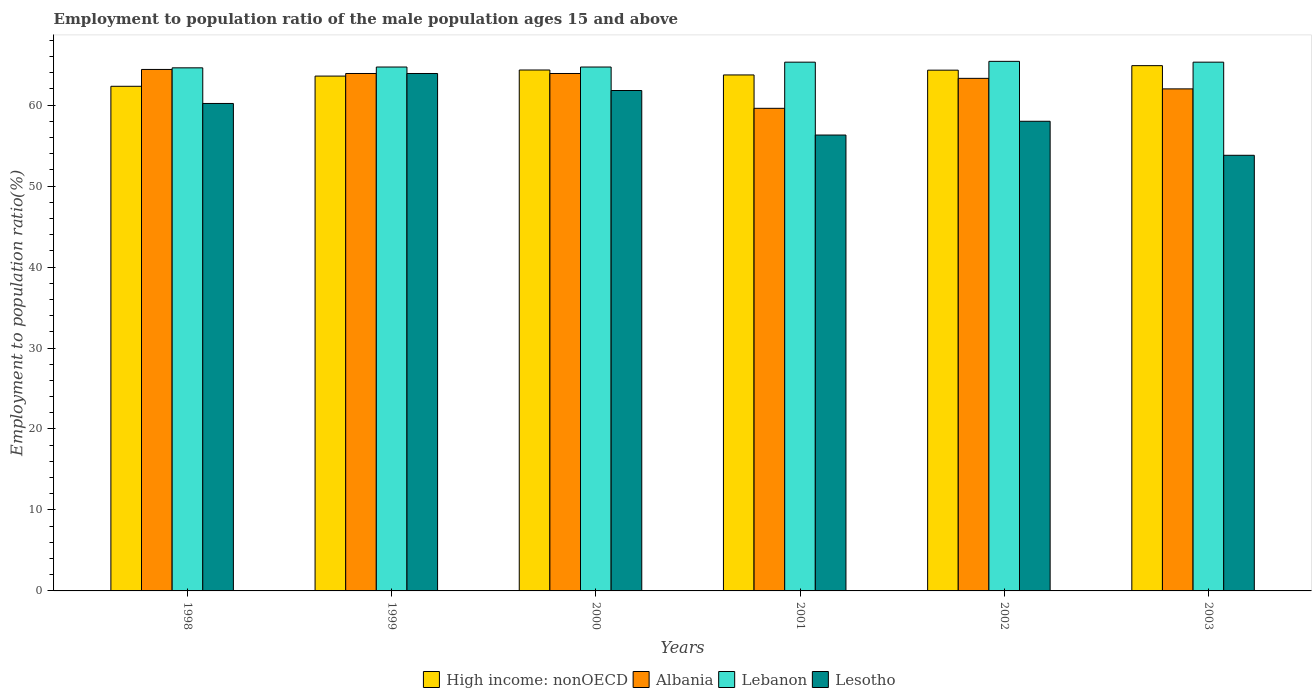How many different coloured bars are there?
Offer a very short reply. 4. Are the number of bars on each tick of the X-axis equal?
Your answer should be compact. Yes. How many bars are there on the 6th tick from the left?
Your answer should be very brief. 4. How many bars are there on the 2nd tick from the right?
Provide a short and direct response. 4. What is the label of the 2nd group of bars from the left?
Your answer should be compact. 1999. In how many cases, is the number of bars for a given year not equal to the number of legend labels?
Offer a very short reply. 0. What is the employment to population ratio in Lesotho in 2002?
Ensure brevity in your answer.  58. Across all years, what is the maximum employment to population ratio in Lesotho?
Offer a very short reply. 63.9. Across all years, what is the minimum employment to population ratio in Albania?
Give a very brief answer. 59.6. In which year was the employment to population ratio in Lebanon maximum?
Keep it short and to the point. 2002. In which year was the employment to population ratio in Lebanon minimum?
Offer a terse response. 1998. What is the total employment to population ratio in High income: nonOECD in the graph?
Make the answer very short. 383.14. What is the difference between the employment to population ratio in Lesotho in 2001 and that in 2002?
Keep it short and to the point. -1.7. What is the difference between the employment to population ratio in Lesotho in 2001 and the employment to population ratio in Albania in 2002?
Your response must be concise. -7. What is the average employment to population ratio in Lesotho per year?
Your answer should be very brief. 59. In the year 2000, what is the difference between the employment to population ratio in Lebanon and employment to population ratio in Lesotho?
Your answer should be very brief. 2.9. In how many years, is the employment to population ratio in High income: nonOECD greater than 14 %?
Provide a succinct answer. 6. What is the ratio of the employment to population ratio in High income: nonOECD in 1999 to that in 2002?
Offer a very short reply. 0.99. Is the employment to population ratio in Lebanon in 2001 less than that in 2002?
Provide a short and direct response. Yes. What is the difference between the highest and the second highest employment to population ratio in Lebanon?
Your answer should be compact. 0.1. What is the difference between the highest and the lowest employment to population ratio in Lesotho?
Your answer should be very brief. 10.1. In how many years, is the employment to population ratio in Lebanon greater than the average employment to population ratio in Lebanon taken over all years?
Provide a short and direct response. 3. Is the sum of the employment to population ratio in Lebanon in 2000 and 2003 greater than the maximum employment to population ratio in Albania across all years?
Keep it short and to the point. Yes. Is it the case that in every year, the sum of the employment to population ratio in Lebanon and employment to population ratio in Albania is greater than the sum of employment to population ratio in High income: nonOECD and employment to population ratio in Lesotho?
Your answer should be very brief. Yes. What does the 1st bar from the left in 1999 represents?
Your answer should be compact. High income: nonOECD. What does the 3rd bar from the right in 1999 represents?
Ensure brevity in your answer.  Albania. Is it the case that in every year, the sum of the employment to population ratio in Lesotho and employment to population ratio in Albania is greater than the employment to population ratio in Lebanon?
Your response must be concise. Yes. Are all the bars in the graph horizontal?
Keep it short and to the point. No. Does the graph contain any zero values?
Your answer should be compact. No. How many legend labels are there?
Provide a succinct answer. 4. How are the legend labels stacked?
Your answer should be compact. Horizontal. What is the title of the graph?
Keep it short and to the point. Employment to population ratio of the male population ages 15 and above. What is the label or title of the X-axis?
Offer a terse response. Years. What is the Employment to population ratio(%) of High income: nonOECD in 1998?
Provide a short and direct response. 62.32. What is the Employment to population ratio(%) in Albania in 1998?
Provide a short and direct response. 64.4. What is the Employment to population ratio(%) in Lebanon in 1998?
Your answer should be compact. 64.6. What is the Employment to population ratio(%) in Lesotho in 1998?
Ensure brevity in your answer.  60.2. What is the Employment to population ratio(%) of High income: nonOECD in 1999?
Keep it short and to the point. 63.58. What is the Employment to population ratio(%) in Albania in 1999?
Your answer should be compact. 63.9. What is the Employment to population ratio(%) of Lebanon in 1999?
Your response must be concise. 64.7. What is the Employment to population ratio(%) in Lesotho in 1999?
Offer a very short reply. 63.9. What is the Employment to population ratio(%) of High income: nonOECD in 2000?
Make the answer very short. 64.33. What is the Employment to population ratio(%) in Albania in 2000?
Your answer should be compact. 63.9. What is the Employment to population ratio(%) of Lebanon in 2000?
Ensure brevity in your answer.  64.7. What is the Employment to population ratio(%) in Lesotho in 2000?
Offer a terse response. 61.8. What is the Employment to population ratio(%) in High income: nonOECD in 2001?
Offer a very short reply. 63.72. What is the Employment to population ratio(%) in Albania in 2001?
Your answer should be compact. 59.6. What is the Employment to population ratio(%) of Lebanon in 2001?
Offer a very short reply. 65.3. What is the Employment to population ratio(%) in Lesotho in 2001?
Make the answer very short. 56.3. What is the Employment to population ratio(%) in High income: nonOECD in 2002?
Offer a terse response. 64.31. What is the Employment to population ratio(%) of Albania in 2002?
Ensure brevity in your answer.  63.3. What is the Employment to population ratio(%) in Lebanon in 2002?
Offer a very short reply. 65.4. What is the Employment to population ratio(%) in Lesotho in 2002?
Make the answer very short. 58. What is the Employment to population ratio(%) in High income: nonOECD in 2003?
Ensure brevity in your answer.  64.87. What is the Employment to population ratio(%) in Lebanon in 2003?
Make the answer very short. 65.3. What is the Employment to population ratio(%) in Lesotho in 2003?
Offer a very short reply. 53.8. Across all years, what is the maximum Employment to population ratio(%) of High income: nonOECD?
Provide a short and direct response. 64.87. Across all years, what is the maximum Employment to population ratio(%) in Albania?
Provide a succinct answer. 64.4. Across all years, what is the maximum Employment to population ratio(%) in Lebanon?
Provide a succinct answer. 65.4. Across all years, what is the maximum Employment to population ratio(%) in Lesotho?
Offer a terse response. 63.9. Across all years, what is the minimum Employment to population ratio(%) in High income: nonOECD?
Provide a short and direct response. 62.32. Across all years, what is the minimum Employment to population ratio(%) in Albania?
Your answer should be compact. 59.6. Across all years, what is the minimum Employment to population ratio(%) of Lebanon?
Give a very brief answer. 64.6. Across all years, what is the minimum Employment to population ratio(%) of Lesotho?
Your response must be concise. 53.8. What is the total Employment to population ratio(%) in High income: nonOECD in the graph?
Keep it short and to the point. 383.14. What is the total Employment to population ratio(%) in Albania in the graph?
Make the answer very short. 377.1. What is the total Employment to population ratio(%) of Lebanon in the graph?
Make the answer very short. 390. What is the total Employment to population ratio(%) in Lesotho in the graph?
Ensure brevity in your answer.  354. What is the difference between the Employment to population ratio(%) of High income: nonOECD in 1998 and that in 1999?
Your answer should be compact. -1.26. What is the difference between the Employment to population ratio(%) in High income: nonOECD in 1998 and that in 2000?
Your response must be concise. -2.01. What is the difference between the Employment to population ratio(%) in Albania in 1998 and that in 2000?
Provide a short and direct response. 0.5. What is the difference between the Employment to population ratio(%) of Lebanon in 1998 and that in 2000?
Provide a short and direct response. -0.1. What is the difference between the Employment to population ratio(%) in High income: nonOECD in 1998 and that in 2001?
Make the answer very short. -1.4. What is the difference between the Employment to population ratio(%) of Albania in 1998 and that in 2001?
Give a very brief answer. 4.8. What is the difference between the Employment to population ratio(%) of Lebanon in 1998 and that in 2001?
Your response must be concise. -0.7. What is the difference between the Employment to population ratio(%) of High income: nonOECD in 1998 and that in 2002?
Offer a terse response. -1.99. What is the difference between the Employment to population ratio(%) in Albania in 1998 and that in 2002?
Your response must be concise. 1.1. What is the difference between the Employment to population ratio(%) of Lebanon in 1998 and that in 2002?
Provide a succinct answer. -0.8. What is the difference between the Employment to population ratio(%) in Lesotho in 1998 and that in 2002?
Provide a succinct answer. 2.2. What is the difference between the Employment to population ratio(%) of High income: nonOECD in 1998 and that in 2003?
Keep it short and to the point. -2.55. What is the difference between the Employment to population ratio(%) of Lebanon in 1998 and that in 2003?
Make the answer very short. -0.7. What is the difference between the Employment to population ratio(%) of High income: nonOECD in 1999 and that in 2000?
Give a very brief answer. -0.75. What is the difference between the Employment to population ratio(%) in High income: nonOECD in 1999 and that in 2001?
Ensure brevity in your answer.  -0.14. What is the difference between the Employment to population ratio(%) of Albania in 1999 and that in 2001?
Provide a short and direct response. 4.3. What is the difference between the Employment to population ratio(%) in High income: nonOECD in 1999 and that in 2002?
Keep it short and to the point. -0.73. What is the difference between the Employment to population ratio(%) in Albania in 1999 and that in 2002?
Provide a succinct answer. 0.6. What is the difference between the Employment to population ratio(%) of Lesotho in 1999 and that in 2002?
Your answer should be compact. 5.9. What is the difference between the Employment to population ratio(%) of High income: nonOECD in 1999 and that in 2003?
Provide a short and direct response. -1.29. What is the difference between the Employment to population ratio(%) of Lebanon in 1999 and that in 2003?
Keep it short and to the point. -0.6. What is the difference between the Employment to population ratio(%) in Lesotho in 1999 and that in 2003?
Keep it short and to the point. 10.1. What is the difference between the Employment to population ratio(%) of High income: nonOECD in 2000 and that in 2001?
Your response must be concise. 0.61. What is the difference between the Employment to population ratio(%) in Albania in 2000 and that in 2001?
Your answer should be compact. 4.3. What is the difference between the Employment to population ratio(%) in High income: nonOECD in 2000 and that in 2002?
Offer a terse response. 0.02. What is the difference between the Employment to population ratio(%) in High income: nonOECD in 2000 and that in 2003?
Your response must be concise. -0.54. What is the difference between the Employment to population ratio(%) in Albania in 2000 and that in 2003?
Provide a short and direct response. 1.9. What is the difference between the Employment to population ratio(%) in Lebanon in 2000 and that in 2003?
Make the answer very short. -0.6. What is the difference between the Employment to population ratio(%) in Lesotho in 2000 and that in 2003?
Give a very brief answer. 8. What is the difference between the Employment to population ratio(%) of High income: nonOECD in 2001 and that in 2002?
Offer a very short reply. -0.59. What is the difference between the Employment to population ratio(%) in Albania in 2001 and that in 2002?
Ensure brevity in your answer.  -3.7. What is the difference between the Employment to population ratio(%) in Lebanon in 2001 and that in 2002?
Your response must be concise. -0.1. What is the difference between the Employment to population ratio(%) of Lesotho in 2001 and that in 2002?
Make the answer very short. -1.7. What is the difference between the Employment to population ratio(%) of High income: nonOECD in 2001 and that in 2003?
Offer a terse response. -1.15. What is the difference between the Employment to population ratio(%) of High income: nonOECD in 2002 and that in 2003?
Make the answer very short. -0.56. What is the difference between the Employment to population ratio(%) of Lebanon in 2002 and that in 2003?
Provide a succinct answer. 0.1. What is the difference between the Employment to population ratio(%) in Lesotho in 2002 and that in 2003?
Your response must be concise. 4.2. What is the difference between the Employment to population ratio(%) in High income: nonOECD in 1998 and the Employment to population ratio(%) in Albania in 1999?
Ensure brevity in your answer.  -1.58. What is the difference between the Employment to population ratio(%) in High income: nonOECD in 1998 and the Employment to population ratio(%) in Lebanon in 1999?
Make the answer very short. -2.38. What is the difference between the Employment to population ratio(%) in High income: nonOECD in 1998 and the Employment to population ratio(%) in Lesotho in 1999?
Provide a succinct answer. -1.58. What is the difference between the Employment to population ratio(%) in Albania in 1998 and the Employment to population ratio(%) in Lebanon in 1999?
Your answer should be very brief. -0.3. What is the difference between the Employment to population ratio(%) of Albania in 1998 and the Employment to population ratio(%) of Lesotho in 1999?
Your answer should be very brief. 0.5. What is the difference between the Employment to population ratio(%) in High income: nonOECD in 1998 and the Employment to population ratio(%) in Albania in 2000?
Your response must be concise. -1.58. What is the difference between the Employment to population ratio(%) of High income: nonOECD in 1998 and the Employment to population ratio(%) of Lebanon in 2000?
Your answer should be very brief. -2.38. What is the difference between the Employment to population ratio(%) of High income: nonOECD in 1998 and the Employment to population ratio(%) of Lesotho in 2000?
Provide a short and direct response. 0.52. What is the difference between the Employment to population ratio(%) in Albania in 1998 and the Employment to population ratio(%) in Lesotho in 2000?
Offer a very short reply. 2.6. What is the difference between the Employment to population ratio(%) of Lebanon in 1998 and the Employment to population ratio(%) of Lesotho in 2000?
Provide a succinct answer. 2.8. What is the difference between the Employment to population ratio(%) in High income: nonOECD in 1998 and the Employment to population ratio(%) in Albania in 2001?
Your answer should be very brief. 2.72. What is the difference between the Employment to population ratio(%) of High income: nonOECD in 1998 and the Employment to population ratio(%) of Lebanon in 2001?
Your answer should be very brief. -2.98. What is the difference between the Employment to population ratio(%) in High income: nonOECD in 1998 and the Employment to population ratio(%) in Lesotho in 2001?
Make the answer very short. 6.02. What is the difference between the Employment to population ratio(%) in Albania in 1998 and the Employment to population ratio(%) in Lebanon in 2001?
Keep it short and to the point. -0.9. What is the difference between the Employment to population ratio(%) in Albania in 1998 and the Employment to population ratio(%) in Lesotho in 2001?
Give a very brief answer. 8.1. What is the difference between the Employment to population ratio(%) in Lebanon in 1998 and the Employment to population ratio(%) in Lesotho in 2001?
Provide a succinct answer. 8.3. What is the difference between the Employment to population ratio(%) in High income: nonOECD in 1998 and the Employment to population ratio(%) in Albania in 2002?
Provide a succinct answer. -0.98. What is the difference between the Employment to population ratio(%) of High income: nonOECD in 1998 and the Employment to population ratio(%) of Lebanon in 2002?
Provide a short and direct response. -3.08. What is the difference between the Employment to population ratio(%) of High income: nonOECD in 1998 and the Employment to population ratio(%) of Lesotho in 2002?
Your response must be concise. 4.32. What is the difference between the Employment to population ratio(%) in Lebanon in 1998 and the Employment to population ratio(%) in Lesotho in 2002?
Make the answer very short. 6.6. What is the difference between the Employment to population ratio(%) of High income: nonOECD in 1998 and the Employment to population ratio(%) of Albania in 2003?
Give a very brief answer. 0.32. What is the difference between the Employment to population ratio(%) of High income: nonOECD in 1998 and the Employment to population ratio(%) of Lebanon in 2003?
Provide a short and direct response. -2.98. What is the difference between the Employment to population ratio(%) in High income: nonOECD in 1998 and the Employment to population ratio(%) in Lesotho in 2003?
Ensure brevity in your answer.  8.52. What is the difference between the Employment to population ratio(%) of Albania in 1998 and the Employment to population ratio(%) of Lesotho in 2003?
Give a very brief answer. 10.6. What is the difference between the Employment to population ratio(%) of High income: nonOECD in 1999 and the Employment to population ratio(%) of Albania in 2000?
Keep it short and to the point. -0.32. What is the difference between the Employment to population ratio(%) in High income: nonOECD in 1999 and the Employment to population ratio(%) in Lebanon in 2000?
Provide a short and direct response. -1.12. What is the difference between the Employment to population ratio(%) in High income: nonOECD in 1999 and the Employment to population ratio(%) in Lesotho in 2000?
Ensure brevity in your answer.  1.78. What is the difference between the Employment to population ratio(%) in Albania in 1999 and the Employment to population ratio(%) in Lebanon in 2000?
Your answer should be compact. -0.8. What is the difference between the Employment to population ratio(%) of Lebanon in 1999 and the Employment to population ratio(%) of Lesotho in 2000?
Give a very brief answer. 2.9. What is the difference between the Employment to population ratio(%) in High income: nonOECD in 1999 and the Employment to population ratio(%) in Albania in 2001?
Offer a very short reply. 3.98. What is the difference between the Employment to population ratio(%) of High income: nonOECD in 1999 and the Employment to population ratio(%) of Lebanon in 2001?
Provide a short and direct response. -1.72. What is the difference between the Employment to population ratio(%) in High income: nonOECD in 1999 and the Employment to population ratio(%) in Lesotho in 2001?
Your response must be concise. 7.28. What is the difference between the Employment to population ratio(%) of Lebanon in 1999 and the Employment to population ratio(%) of Lesotho in 2001?
Provide a short and direct response. 8.4. What is the difference between the Employment to population ratio(%) of High income: nonOECD in 1999 and the Employment to population ratio(%) of Albania in 2002?
Offer a very short reply. 0.28. What is the difference between the Employment to population ratio(%) of High income: nonOECD in 1999 and the Employment to population ratio(%) of Lebanon in 2002?
Make the answer very short. -1.82. What is the difference between the Employment to population ratio(%) of High income: nonOECD in 1999 and the Employment to population ratio(%) of Lesotho in 2002?
Give a very brief answer. 5.58. What is the difference between the Employment to population ratio(%) in Albania in 1999 and the Employment to population ratio(%) in Lesotho in 2002?
Your response must be concise. 5.9. What is the difference between the Employment to population ratio(%) in High income: nonOECD in 1999 and the Employment to population ratio(%) in Albania in 2003?
Your answer should be very brief. 1.58. What is the difference between the Employment to population ratio(%) of High income: nonOECD in 1999 and the Employment to population ratio(%) of Lebanon in 2003?
Offer a terse response. -1.72. What is the difference between the Employment to population ratio(%) of High income: nonOECD in 1999 and the Employment to population ratio(%) of Lesotho in 2003?
Give a very brief answer. 9.78. What is the difference between the Employment to population ratio(%) of Albania in 1999 and the Employment to population ratio(%) of Lebanon in 2003?
Your response must be concise. -1.4. What is the difference between the Employment to population ratio(%) in High income: nonOECD in 2000 and the Employment to population ratio(%) in Albania in 2001?
Offer a very short reply. 4.73. What is the difference between the Employment to population ratio(%) in High income: nonOECD in 2000 and the Employment to population ratio(%) in Lebanon in 2001?
Keep it short and to the point. -0.97. What is the difference between the Employment to population ratio(%) in High income: nonOECD in 2000 and the Employment to population ratio(%) in Lesotho in 2001?
Provide a short and direct response. 8.03. What is the difference between the Employment to population ratio(%) of Albania in 2000 and the Employment to population ratio(%) of Lebanon in 2001?
Provide a succinct answer. -1.4. What is the difference between the Employment to population ratio(%) in Albania in 2000 and the Employment to population ratio(%) in Lesotho in 2001?
Keep it short and to the point. 7.6. What is the difference between the Employment to population ratio(%) in High income: nonOECD in 2000 and the Employment to population ratio(%) in Albania in 2002?
Your answer should be compact. 1.03. What is the difference between the Employment to population ratio(%) in High income: nonOECD in 2000 and the Employment to population ratio(%) in Lebanon in 2002?
Provide a succinct answer. -1.07. What is the difference between the Employment to population ratio(%) in High income: nonOECD in 2000 and the Employment to population ratio(%) in Lesotho in 2002?
Provide a succinct answer. 6.33. What is the difference between the Employment to population ratio(%) in Albania in 2000 and the Employment to population ratio(%) in Lebanon in 2002?
Make the answer very short. -1.5. What is the difference between the Employment to population ratio(%) of Albania in 2000 and the Employment to population ratio(%) of Lesotho in 2002?
Provide a succinct answer. 5.9. What is the difference between the Employment to population ratio(%) of High income: nonOECD in 2000 and the Employment to population ratio(%) of Albania in 2003?
Your response must be concise. 2.33. What is the difference between the Employment to population ratio(%) of High income: nonOECD in 2000 and the Employment to population ratio(%) of Lebanon in 2003?
Ensure brevity in your answer.  -0.97. What is the difference between the Employment to population ratio(%) in High income: nonOECD in 2000 and the Employment to population ratio(%) in Lesotho in 2003?
Your answer should be very brief. 10.53. What is the difference between the Employment to population ratio(%) in High income: nonOECD in 2001 and the Employment to population ratio(%) in Albania in 2002?
Your response must be concise. 0.42. What is the difference between the Employment to population ratio(%) in High income: nonOECD in 2001 and the Employment to population ratio(%) in Lebanon in 2002?
Your answer should be very brief. -1.68. What is the difference between the Employment to population ratio(%) of High income: nonOECD in 2001 and the Employment to population ratio(%) of Lesotho in 2002?
Provide a short and direct response. 5.72. What is the difference between the Employment to population ratio(%) in Albania in 2001 and the Employment to population ratio(%) in Lebanon in 2002?
Offer a very short reply. -5.8. What is the difference between the Employment to population ratio(%) of Albania in 2001 and the Employment to population ratio(%) of Lesotho in 2002?
Provide a short and direct response. 1.6. What is the difference between the Employment to population ratio(%) of High income: nonOECD in 2001 and the Employment to population ratio(%) of Albania in 2003?
Provide a succinct answer. 1.72. What is the difference between the Employment to population ratio(%) in High income: nonOECD in 2001 and the Employment to population ratio(%) in Lebanon in 2003?
Ensure brevity in your answer.  -1.58. What is the difference between the Employment to population ratio(%) in High income: nonOECD in 2001 and the Employment to population ratio(%) in Lesotho in 2003?
Keep it short and to the point. 9.92. What is the difference between the Employment to population ratio(%) in Albania in 2001 and the Employment to population ratio(%) in Lebanon in 2003?
Your answer should be very brief. -5.7. What is the difference between the Employment to population ratio(%) in Albania in 2001 and the Employment to population ratio(%) in Lesotho in 2003?
Ensure brevity in your answer.  5.8. What is the difference between the Employment to population ratio(%) in Lebanon in 2001 and the Employment to population ratio(%) in Lesotho in 2003?
Make the answer very short. 11.5. What is the difference between the Employment to population ratio(%) of High income: nonOECD in 2002 and the Employment to population ratio(%) of Albania in 2003?
Your answer should be compact. 2.31. What is the difference between the Employment to population ratio(%) in High income: nonOECD in 2002 and the Employment to population ratio(%) in Lebanon in 2003?
Offer a terse response. -0.99. What is the difference between the Employment to population ratio(%) of High income: nonOECD in 2002 and the Employment to population ratio(%) of Lesotho in 2003?
Ensure brevity in your answer.  10.51. What is the difference between the Employment to population ratio(%) of Albania in 2002 and the Employment to population ratio(%) of Lebanon in 2003?
Offer a very short reply. -2. What is the difference between the Employment to population ratio(%) of Albania in 2002 and the Employment to population ratio(%) of Lesotho in 2003?
Keep it short and to the point. 9.5. What is the average Employment to population ratio(%) in High income: nonOECD per year?
Your answer should be very brief. 63.86. What is the average Employment to population ratio(%) in Albania per year?
Offer a very short reply. 62.85. What is the average Employment to population ratio(%) in Lebanon per year?
Offer a terse response. 65. In the year 1998, what is the difference between the Employment to population ratio(%) of High income: nonOECD and Employment to population ratio(%) of Albania?
Offer a terse response. -2.08. In the year 1998, what is the difference between the Employment to population ratio(%) in High income: nonOECD and Employment to population ratio(%) in Lebanon?
Your response must be concise. -2.28. In the year 1998, what is the difference between the Employment to population ratio(%) in High income: nonOECD and Employment to population ratio(%) in Lesotho?
Provide a succinct answer. 2.12. In the year 1998, what is the difference between the Employment to population ratio(%) of Albania and Employment to population ratio(%) of Lesotho?
Provide a short and direct response. 4.2. In the year 1998, what is the difference between the Employment to population ratio(%) of Lebanon and Employment to population ratio(%) of Lesotho?
Offer a very short reply. 4.4. In the year 1999, what is the difference between the Employment to population ratio(%) of High income: nonOECD and Employment to population ratio(%) of Albania?
Your response must be concise. -0.32. In the year 1999, what is the difference between the Employment to population ratio(%) of High income: nonOECD and Employment to population ratio(%) of Lebanon?
Ensure brevity in your answer.  -1.12. In the year 1999, what is the difference between the Employment to population ratio(%) of High income: nonOECD and Employment to population ratio(%) of Lesotho?
Keep it short and to the point. -0.32. In the year 2000, what is the difference between the Employment to population ratio(%) in High income: nonOECD and Employment to population ratio(%) in Albania?
Your answer should be very brief. 0.43. In the year 2000, what is the difference between the Employment to population ratio(%) in High income: nonOECD and Employment to population ratio(%) in Lebanon?
Your answer should be very brief. -0.37. In the year 2000, what is the difference between the Employment to population ratio(%) in High income: nonOECD and Employment to population ratio(%) in Lesotho?
Your answer should be very brief. 2.53. In the year 2000, what is the difference between the Employment to population ratio(%) in Albania and Employment to population ratio(%) in Lebanon?
Provide a short and direct response. -0.8. In the year 2000, what is the difference between the Employment to population ratio(%) in Albania and Employment to population ratio(%) in Lesotho?
Your answer should be compact. 2.1. In the year 2001, what is the difference between the Employment to population ratio(%) of High income: nonOECD and Employment to population ratio(%) of Albania?
Offer a terse response. 4.12. In the year 2001, what is the difference between the Employment to population ratio(%) of High income: nonOECD and Employment to population ratio(%) of Lebanon?
Offer a very short reply. -1.58. In the year 2001, what is the difference between the Employment to population ratio(%) of High income: nonOECD and Employment to population ratio(%) of Lesotho?
Give a very brief answer. 7.42. In the year 2001, what is the difference between the Employment to population ratio(%) of Albania and Employment to population ratio(%) of Lebanon?
Offer a very short reply. -5.7. In the year 2001, what is the difference between the Employment to population ratio(%) of Albania and Employment to population ratio(%) of Lesotho?
Your response must be concise. 3.3. In the year 2001, what is the difference between the Employment to population ratio(%) in Lebanon and Employment to population ratio(%) in Lesotho?
Provide a succinct answer. 9. In the year 2002, what is the difference between the Employment to population ratio(%) in High income: nonOECD and Employment to population ratio(%) in Albania?
Provide a short and direct response. 1.01. In the year 2002, what is the difference between the Employment to population ratio(%) in High income: nonOECD and Employment to population ratio(%) in Lebanon?
Offer a very short reply. -1.09. In the year 2002, what is the difference between the Employment to population ratio(%) in High income: nonOECD and Employment to population ratio(%) in Lesotho?
Offer a very short reply. 6.31. In the year 2002, what is the difference between the Employment to population ratio(%) of Albania and Employment to population ratio(%) of Lebanon?
Provide a succinct answer. -2.1. In the year 2002, what is the difference between the Employment to population ratio(%) in Albania and Employment to population ratio(%) in Lesotho?
Offer a terse response. 5.3. In the year 2002, what is the difference between the Employment to population ratio(%) of Lebanon and Employment to population ratio(%) of Lesotho?
Offer a very short reply. 7.4. In the year 2003, what is the difference between the Employment to population ratio(%) of High income: nonOECD and Employment to population ratio(%) of Albania?
Offer a terse response. 2.87. In the year 2003, what is the difference between the Employment to population ratio(%) of High income: nonOECD and Employment to population ratio(%) of Lebanon?
Your response must be concise. -0.43. In the year 2003, what is the difference between the Employment to population ratio(%) in High income: nonOECD and Employment to population ratio(%) in Lesotho?
Offer a very short reply. 11.07. In the year 2003, what is the difference between the Employment to population ratio(%) of Lebanon and Employment to population ratio(%) of Lesotho?
Your answer should be compact. 11.5. What is the ratio of the Employment to population ratio(%) of High income: nonOECD in 1998 to that in 1999?
Provide a succinct answer. 0.98. What is the ratio of the Employment to population ratio(%) in Albania in 1998 to that in 1999?
Offer a terse response. 1.01. What is the ratio of the Employment to population ratio(%) in Lebanon in 1998 to that in 1999?
Offer a terse response. 1. What is the ratio of the Employment to population ratio(%) in Lesotho in 1998 to that in 1999?
Offer a terse response. 0.94. What is the ratio of the Employment to population ratio(%) of High income: nonOECD in 1998 to that in 2000?
Your answer should be very brief. 0.97. What is the ratio of the Employment to population ratio(%) of Albania in 1998 to that in 2000?
Your response must be concise. 1.01. What is the ratio of the Employment to population ratio(%) in Lebanon in 1998 to that in 2000?
Make the answer very short. 1. What is the ratio of the Employment to population ratio(%) in Lesotho in 1998 to that in 2000?
Provide a short and direct response. 0.97. What is the ratio of the Employment to population ratio(%) in High income: nonOECD in 1998 to that in 2001?
Keep it short and to the point. 0.98. What is the ratio of the Employment to population ratio(%) in Albania in 1998 to that in 2001?
Make the answer very short. 1.08. What is the ratio of the Employment to population ratio(%) in Lebanon in 1998 to that in 2001?
Offer a very short reply. 0.99. What is the ratio of the Employment to population ratio(%) in Lesotho in 1998 to that in 2001?
Offer a terse response. 1.07. What is the ratio of the Employment to population ratio(%) in High income: nonOECD in 1998 to that in 2002?
Your answer should be compact. 0.97. What is the ratio of the Employment to population ratio(%) in Albania in 1998 to that in 2002?
Provide a succinct answer. 1.02. What is the ratio of the Employment to population ratio(%) in Lesotho in 1998 to that in 2002?
Your answer should be compact. 1.04. What is the ratio of the Employment to population ratio(%) in High income: nonOECD in 1998 to that in 2003?
Provide a short and direct response. 0.96. What is the ratio of the Employment to population ratio(%) in Albania in 1998 to that in 2003?
Offer a terse response. 1.04. What is the ratio of the Employment to population ratio(%) in Lebanon in 1998 to that in 2003?
Keep it short and to the point. 0.99. What is the ratio of the Employment to population ratio(%) of Lesotho in 1998 to that in 2003?
Give a very brief answer. 1.12. What is the ratio of the Employment to population ratio(%) of High income: nonOECD in 1999 to that in 2000?
Offer a very short reply. 0.99. What is the ratio of the Employment to population ratio(%) of Albania in 1999 to that in 2000?
Keep it short and to the point. 1. What is the ratio of the Employment to population ratio(%) of Lebanon in 1999 to that in 2000?
Your answer should be very brief. 1. What is the ratio of the Employment to population ratio(%) of Lesotho in 1999 to that in 2000?
Your response must be concise. 1.03. What is the ratio of the Employment to population ratio(%) of High income: nonOECD in 1999 to that in 2001?
Make the answer very short. 1. What is the ratio of the Employment to population ratio(%) of Albania in 1999 to that in 2001?
Your answer should be compact. 1.07. What is the ratio of the Employment to population ratio(%) of Lesotho in 1999 to that in 2001?
Keep it short and to the point. 1.14. What is the ratio of the Employment to population ratio(%) of Albania in 1999 to that in 2002?
Offer a very short reply. 1.01. What is the ratio of the Employment to population ratio(%) in Lebanon in 1999 to that in 2002?
Offer a very short reply. 0.99. What is the ratio of the Employment to population ratio(%) of Lesotho in 1999 to that in 2002?
Make the answer very short. 1.1. What is the ratio of the Employment to population ratio(%) of High income: nonOECD in 1999 to that in 2003?
Give a very brief answer. 0.98. What is the ratio of the Employment to population ratio(%) in Albania in 1999 to that in 2003?
Your response must be concise. 1.03. What is the ratio of the Employment to population ratio(%) of Lesotho in 1999 to that in 2003?
Make the answer very short. 1.19. What is the ratio of the Employment to population ratio(%) of High income: nonOECD in 2000 to that in 2001?
Your answer should be compact. 1.01. What is the ratio of the Employment to population ratio(%) in Albania in 2000 to that in 2001?
Keep it short and to the point. 1.07. What is the ratio of the Employment to population ratio(%) of Lesotho in 2000 to that in 2001?
Provide a succinct answer. 1.1. What is the ratio of the Employment to population ratio(%) of High income: nonOECD in 2000 to that in 2002?
Your response must be concise. 1. What is the ratio of the Employment to population ratio(%) in Albania in 2000 to that in 2002?
Provide a short and direct response. 1.01. What is the ratio of the Employment to population ratio(%) of Lebanon in 2000 to that in 2002?
Provide a succinct answer. 0.99. What is the ratio of the Employment to population ratio(%) in Lesotho in 2000 to that in 2002?
Keep it short and to the point. 1.07. What is the ratio of the Employment to population ratio(%) in Albania in 2000 to that in 2003?
Provide a succinct answer. 1.03. What is the ratio of the Employment to population ratio(%) in Lebanon in 2000 to that in 2003?
Offer a very short reply. 0.99. What is the ratio of the Employment to population ratio(%) of Lesotho in 2000 to that in 2003?
Offer a very short reply. 1.15. What is the ratio of the Employment to population ratio(%) of High income: nonOECD in 2001 to that in 2002?
Provide a succinct answer. 0.99. What is the ratio of the Employment to population ratio(%) in Albania in 2001 to that in 2002?
Your answer should be compact. 0.94. What is the ratio of the Employment to population ratio(%) in Lesotho in 2001 to that in 2002?
Offer a very short reply. 0.97. What is the ratio of the Employment to population ratio(%) of High income: nonOECD in 2001 to that in 2003?
Your response must be concise. 0.98. What is the ratio of the Employment to population ratio(%) in Albania in 2001 to that in 2003?
Your answer should be compact. 0.96. What is the ratio of the Employment to population ratio(%) in Lebanon in 2001 to that in 2003?
Your answer should be very brief. 1. What is the ratio of the Employment to population ratio(%) in Lesotho in 2001 to that in 2003?
Make the answer very short. 1.05. What is the ratio of the Employment to population ratio(%) in High income: nonOECD in 2002 to that in 2003?
Offer a terse response. 0.99. What is the ratio of the Employment to population ratio(%) of Lebanon in 2002 to that in 2003?
Provide a short and direct response. 1. What is the ratio of the Employment to population ratio(%) of Lesotho in 2002 to that in 2003?
Offer a terse response. 1.08. What is the difference between the highest and the second highest Employment to population ratio(%) of High income: nonOECD?
Your response must be concise. 0.54. What is the difference between the highest and the lowest Employment to population ratio(%) in High income: nonOECD?
Your response must be concise. 2.55. What is the difference between the highest and the lowest Employment to population ratio(%) in Lesotho?
Offer a terse response. 10.1. 